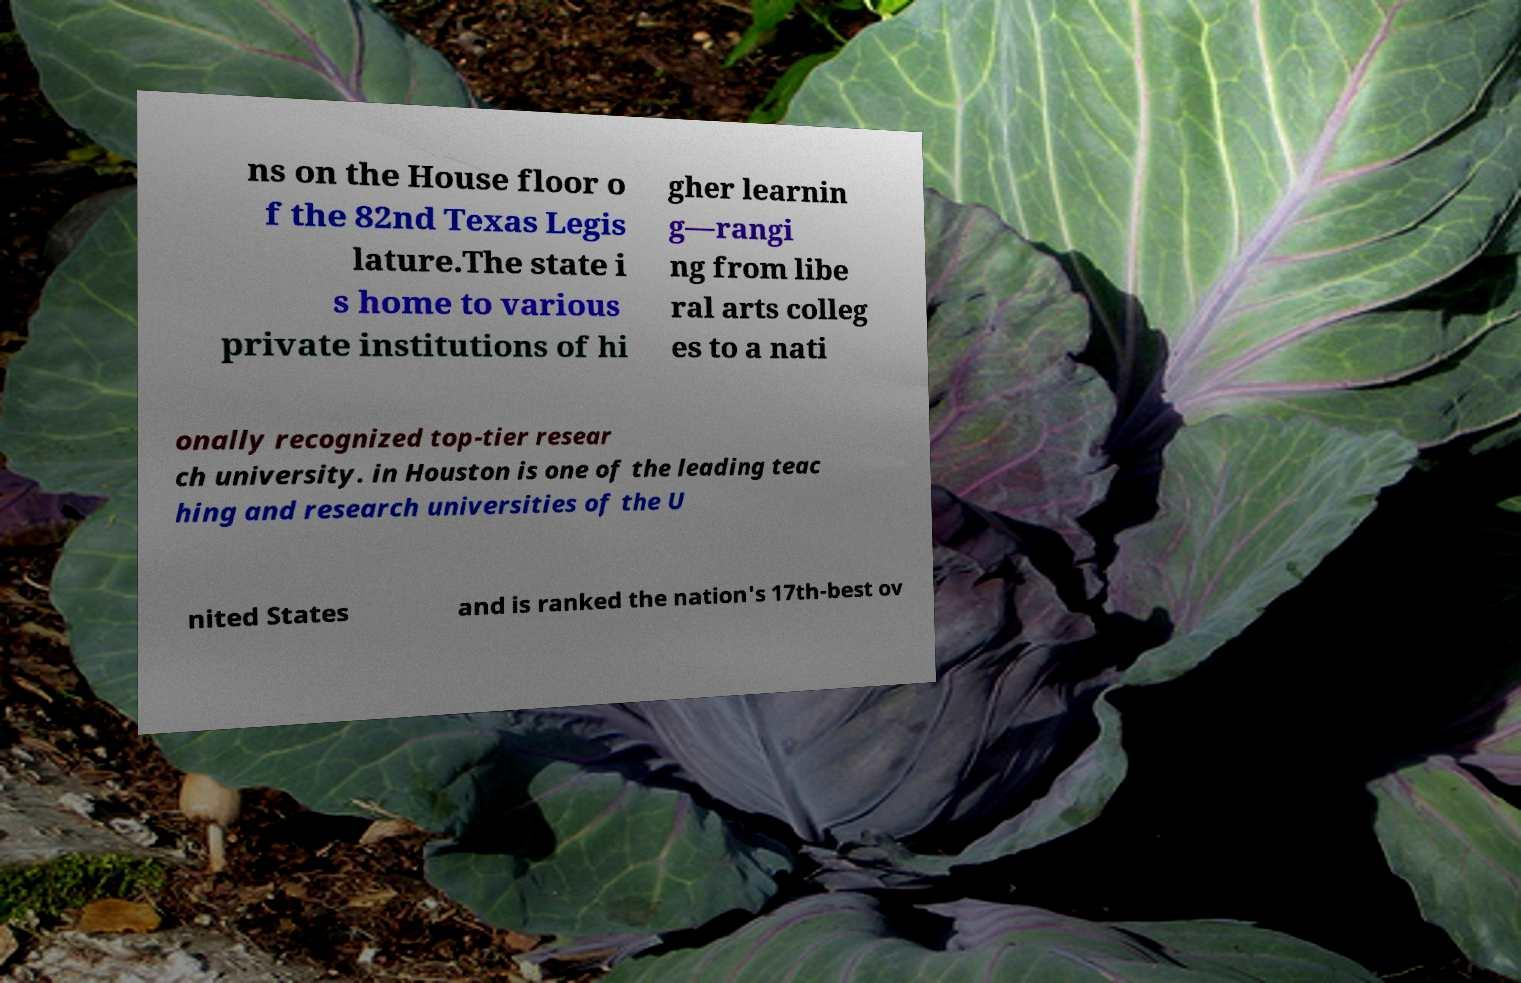What messages or text are displayed in this image? I need them in a readable, typed format. ns on the House floor o f the 82nd Texas Legis lature.The state i s home to various private institutions of hi gher learnin g—rangi ng from libe ral arts colleg es to a nati onally recognized top-tier resear ch university. in Houston is one of the leading teac hing and research universities of the U nited States and is ranked the nation's 17th-best ov 